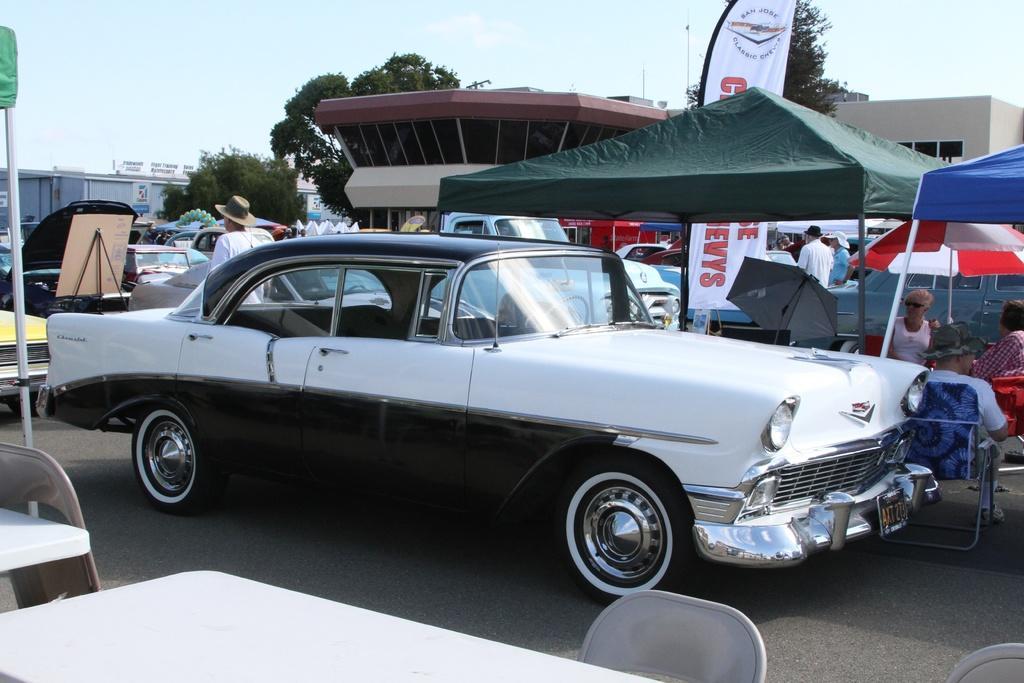Describe this image in one or two sentences. In this picture we can see vehicles on the road, tables, buildings, trees, banners, tents and a group of people where some are sitting on chairs and some are standing and in the background we can see the sky with clouds. 